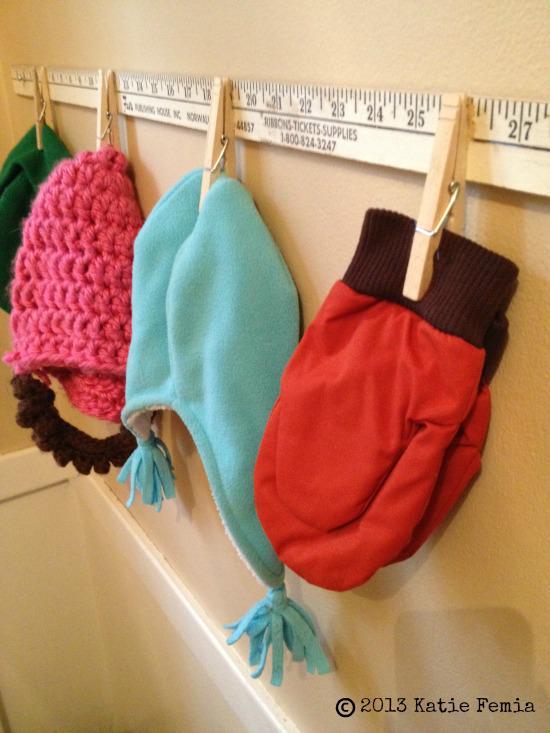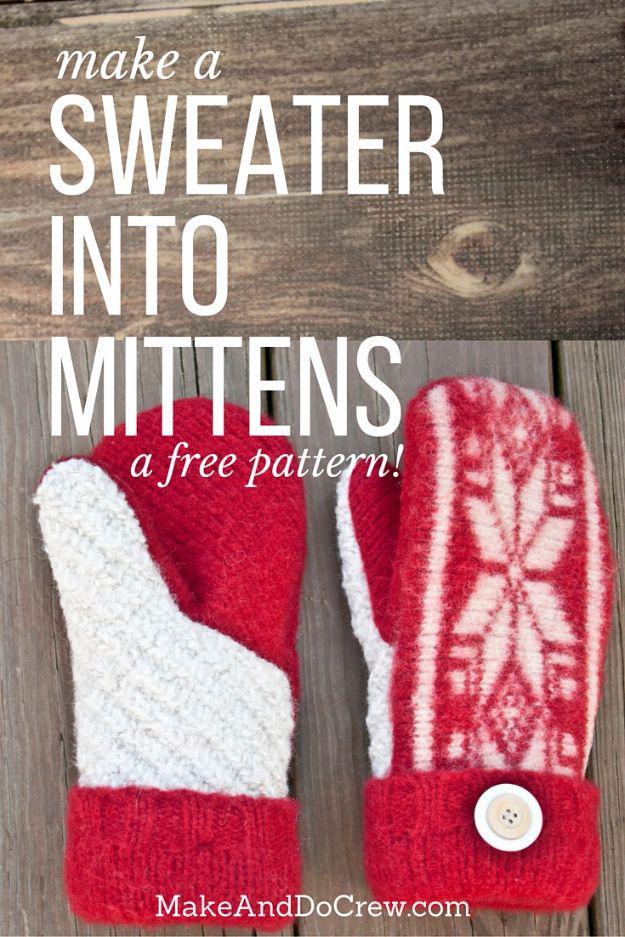The first image is the image on the left, the second image is the image on the right. Assess this claim about the two images: "An image shows exactly three unworn items of apparel, and at least two are gloves with fingers.". Correct or not? Answer yes or no. No. The first image is the image on the left, the second image is the image on the right. Analyze the images presented: Is the assertion "The left and right image contains the same number of red mittens." valid? Answer yes or no. Yes. 